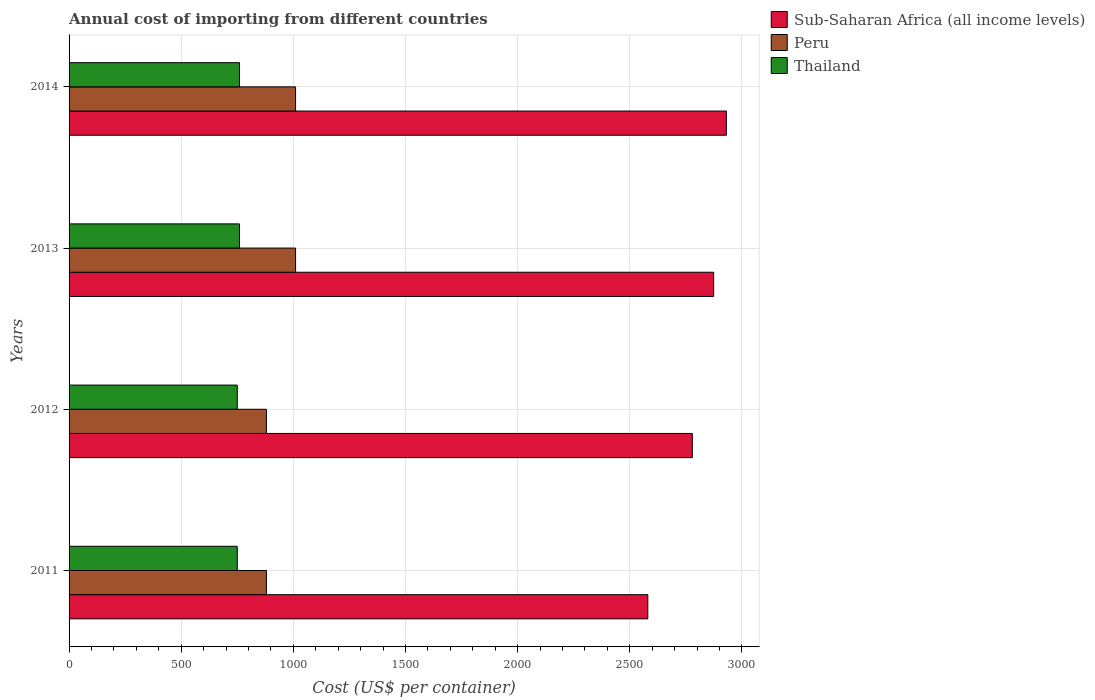How many different coloured bars are there?
Offer a very short reply. 3. How many groups of bars are there?
Your response must be concise. 4. Are the number of bars per tick equal to the number of legend labels?
Make the answer very short. Yes. How many bars are there on the 1st tick from the top?
Make the answer very short. 3. What is the label of the 3rd group of bars from the top?
Your answer should be compact. 2012. In how many cases, is the number of bars for a given year not equal to the number of legend labels?
Give a very brief answer. 0. What is the total annual cost of importing in Peru in 2014?
Your response must be concise. 1010. Across all years, what is the maximum total annual cost of importing in Peru?
Keep it short and to the point. 1010. Across all years, what is the minimum total annual cost of importing in Thailand?
Provide a short and direct response. 750. In which year was the total annual cost of importing in Peru maximum?
Keep it short and to the point. 2013. What is the total total annual cost of importing in Peru in the graph?
Your answer should be very brief. 3780. What is the difference between the total annual cost of importing in Thailand in 2012 and that in 2014?
Your answer should be compact. -10. What is the difference between the total annual cost of importing in Sub-Saharan Africa (all income levels) in 2011 and the total annual cost of importing in Thailand in 2012?
Provide a short and direct response. 1830.65. What is the average total annual cost of importing in Sub-Saharan Africa (all income levels) per year?
Keep it short and to the point. 2791.25. In the year 2012, what is the difference between the total annual cost of importing in Thailand and total annual cost of importing in Sub-Saharan Africa (all income levels)?
Your answer should be compact. -2029.19. In how many years, is the total annual cost of importing in Peru greater than 500 US$?
Offer a very short reply. 4. What is the ratio of the total annual cost of importing in Thailand in 2011 to that in 2014?
Your response must be concise. 0.99. Is the total annual cost of importing in Sub-Saharan Africa (all income levels) in 2011 less than that in 2013?
Ensure brevity in your answer.  Yes. Is the difference between the total annual cost of importing in Thailand in 2011 and 2012 greater than the difference between the total annual cost of importing in Sub-Saharan Africa (all income levels) in 2011 and 2012?
Your answer should be compact. Yes. What is the difference between the highest and the lowest total annual cost of importing in Thailand?
Your answer should be compact. 10. In how many years, is the total annual cost of importing in Thailand greater than the average total annual cost of importing in Thailand taken over all years?
Provide a short and direct response. 2. Is the sum of the total annual cost of importing in Thailand in 2012 and 2014 greater than the maximum total annual cost of importing in Peru across all years?
Make the answer very short. Yes. What does the 1st bar from the bottom in 2013 represents?
Give a very brief answer. Sub-Saharan Africa (all income levels). Is it the case that in every year, the sum of the total annual cost of importing in Peru and total annual cost of importing in Sub-Saharan Africa (all income levels) is greater than the total annual cost of importing in Thailand?
Your answer should be very brief. Yes. How many bars are there?
Your answer should be very brief. 12. Are all the bars in the graph horizontal?
Your answer should be compact. Yes. What is the difference between two consecutive major ticks on the X-axis?
Provide a succinct answer. 500. Are the values on the major ticks of X-axis written in scientific E-notation?
Ensure brevity in your answer.  No. Does the graph contain any zero values?
Keep it short and to the point. No. Where does the legend appear in the graph?
Your answer should be compact. Top right. What is the title of the graph?
Ensure brevity in your answer.  Annual cost of importing from different countries. What is the label or title of the X-axis?
Ensure brevity in your answer.  Cost (US$ per container). What is the Cost (US$ per container) in Sub-Saharan Africa (all income levels) in 2011?
Give a very brief answer. 2580.65. What is the Cost (US$ per container) of Peru in 2011?
Your response must be concise. 880. What is the Cost (US$ per container) in Thailand in 2011?
Provide a short and direct response. 750. What is the Cost (US$ per container) in Sub-Saharan Africa (all income levels) in 2012?
Your answer should be very brief. 2779.19. What is the Cost (US$ per container) in Peru in 2012?
Your response must be concise. 880. What is the Cost (US$ per container) of Thailand in 2012?
Provide a succinct answer. 750. What is the Cost (US$ per container) of Sub-Saharan Africa (all income levels) in 2013?
Your response must be concise. 2874.2. What is the Cost (US$ per container) of Peru in 2013?
Your response must be concise. 1010. What is the Cost (US$ per container) of Thailand in 2013?
Your response must be concise. 760. What is the Cost (US$ per container) of Sub-Saharan Africa (all income levels) in 2014?
Offer a very short reply. 2930.95. What is the Cost (US$ per container) of Peru in 2014?
Make the answer very short. 1010. What is the Cost (US$ per container) of Thailand in 2014?
Provide a short and direct response. 760. Across all years, what is the maximum Cost (US$ per container) in Sub-Saharan Africa (all income levels)?
Ensure brevity in your answer.  2930.95. Across all years, what is the maximum Cost (US$ per container) of Peru?
Your answer should be compact. 1010. Across all years, what is the maximum Cost (US$ per container) of Thailand?
Offer a terse response. 760. Across all years, what is the minimum Cost (US$ per container) of Sub-Saharan Africa (all income levels)?
Give a very brief answer. 2580.65. Across all years, what is the minimum Cost (US$ per container) in Peru?
Offer a terse response. 880. Across all years, what is the minimum Cost (US$ per container) in Thailand?
Offer a very short reply. 750. What is the total Cost (US$ per container) in Sub-Saharan Africa (all income levels) in the graph?
Give a very brief answer. 1.12e+04. What is the total Cost (US$ per container) of Peru in the graph?
Ensure brevity in your answer.  3780. What is the total Cost (US$ per container) in Thailand in the graph?
Your answer should be very brief. 3020. What is the difference between the Cost (US$ per container) in Sub-Saharan Africa (all income levels) in 2011 and that in 2012?
Give a very brief answer. -198.54. What is the difference between the Cost (US$ per container) of Thailand in 2011 and that in 2012?
Your answer should be compact. 0. What is the difference between the Cost (US$ per container) of Sub-Saharan Africa (all income levels) in 2011 and that in 2013?
Ensure brevity in your answer.  -293.55. What is the difference between the Cost (US$ per container) of Peru in 2011 and that in 2013?
Your response must be concise. -130. What is the difference between the Cost (US$ per container) in Sub-Saharan Africa (all income levels) in 2011 and that in 2014?
Your response must be concise. -350.29. What is the difference between the Cost (US$ per container) in Peru in 2011 and that in 2014?
Provide a short and direct response. -130. What is the difference between the Cost (US$ per container) in Thailand in 2011 and that in 2014?
Offer a terse response. -10. What is the difference between the Cost (US$ per container) of Sub-Saharan Africa (all income levels) in 2012 and that in 2013?
Provide a succinct answer. -95.01. What is the difference between the Cost (US$ per container) in Peru in 2012 and that in 2013?
Offer a very short reply. -130. What is the difference between the Cost (US$ per container) in Thailand in 2012 and that in 2013?
Your answer should be very brief. -10. What is the difference between the Cost (US$ per container) in Sub-Saharan Africa (all income levels) in 2012 and that in 2014?
Provide a short and direct response. -151.76. What is the difference between the Cost (US$ per container) in Peru in 2012 and that in 2014?
Make the answer very short. -130. What is the difference between the Cost (US$ per container) in Thailand in 2012 and that in 2014?
Keep it short and to the point. -10. What is the difference between the Cost (US$ per container) in Sub-Saharan Africa (all income levels) in 2013 and that in 2014?
Your response must be concise. -56.74. What is the difference between the Cost (US$ per container) of Sub-Saharan Africa (all income levels) in 2011 and the Cost (US$ per container) of Peru in 2012?
Offer a terse response. 1700.65. What is the difference between the Cost (US$ per container) of Sub-Saharan Africa (all income levels) in 2011 and the Cost (US$ per container) of Thailand in 2012?
Make the answer very short. 1830.65. What is the difference between the Cost (US$ per container) in Peru in 2011 and the Cost (US$ per container) in Thailand in 2012?
Your response must be concise. 130. What is the difference between the Cost (US$ per container) of Sub-Saharan Africa (all income levels) in 2011 and the Cost (US$ per container) of Peru in 2013?
Provide a succinct answer. 1570.65. What is the difference between the Cost (US$ per container) of Sub-Saharan Africa (all income levels) in 2011 and the Cost (US$ per container) of Thailand in 2013?
Provide a short and direct response. 1820.65. What is the difference between the Cost (US$ per container) in Peru in 2011 and the Cost (US$ per container) in Thailand in 2013?
Provide a short and direct response. 120. What is the difference between the Cost (US$ per container) of Sub-Saharan Africa (all income levels) in 2011 and the Cost (US$ per container) of Peru in 2014?
Offer a terse response. 1570.65. What is the difference between the Cost (US$ per container) of Sub-Saharan Africa (all income levels) in 2011 and the Cost (US$ per container) of Thailand in 2014?
Ensure brevity in your answer.  1820.65. What is the difference between the Cost (US$ per container) of Peru in 2011 and the Cost (US$ per container) of Thailand in 2014?
Your answer should be very brief. 120. What is the difference between the Cost (US$ per container) of Sub-Saharan Africa (all income levels) in 2012 and the Cost (US$ per container) of Peru in 2013?
Your answer should be compact. 1769.19. What is the difference between the Cost (US$ per container) in Sub-Saharan Africa (all income levels) in 2012 and the Cost (US$ per container) in Thailand in 2013?
Ensure brevity in your answer.  2019.19. What is the difference between the Cost (US$ per container) of Peru in 2012 and the Cost (US$ per container) of Thailand in 2013?
Give a very brief answer. 120. What is the difference between the Cost (US$ per container) of Sub-Saharan Africa (all income levels) in 2012 and the Cost (US$ per container) of Peru in 2014?
Your response must be concise. 1769.19. What is the difference between the Cost (US$ per container) of Sub-Saharan Africa (all income levels) in 2012 and the Cost (US$ per container) of Thailand in 2014?
Your response must be concise. 2019.19. What is the difference between the Cost (US$ per container) of Peru in 2012 and the Cost (US$ per container) of Thailand in 2014?
Your answer should be very brief. 120. What is the difference between the Cost (US$ per container) of Sub-Saharan Africa (all income levels) in 2013 and the Cost (US$ per container) of Peru in 2014?
Your response must be concise. 1864.2. What is the difference between the Cost (US$ per container) of Sub-Saharan Africa (all income levels) in 2013 and the Cost (US$ per container) of Thailand in 2014?
Provide a succinct answer. 2114.2. What is the difference between the Cost (US$ per container) in Peru in 2013 and the Cost (US$ per container) in Thailand in 2014?
Your answer should be compact. 250. What is the average Cost (US$ per container) in Sub-Saharan Africa (all income levels) per year?
Ensure brevity in your answer.  2791.25. What is the average Cost (US$ per container) of Peru per year?
Make the answer very short. 945. What is the average Cost (US$ per container) in Thailand per year?
Keep it short and to the point. 755. In the year 2011, what is the difference between the Cost (US$ per container) in Sub-Saharan Africa (all income levels) and Cost (US$ per container) in Peru?
Provide a short and direct response. 1700.65. In the year 2011, what is the difference between the Cost (US$ per container) in Sub-Saharan Africa (all income levels) and Cost (US$ per container) in Thailand?
Keep it short and to the point. 1830.65. In the year 2011, what is the difference between the Cost (US$ per container) in Peru and Cost (US$ per container) in Thailand?
Your answer should be compact. 130. In the year 2012, what is the difference between the Cost (US$ per container) in Sub-Saharan Africa (all income levels) and Cost (US$ per container) in Peru?
Your answer should be compact. 1899.19. In the year 2012, what is the difference between the Cost (US$ per container) in Sub-Saharan Africa (all income levels) and Cost (US$ per container) in Thailand?
Ensure brevity in your answer.  2029.19. In the year 2012, what is the difference between the Cost (US$ per container) in Peru and Cost (US$ per container) in Thailand?
Provide a short and direct response. 130. In the year 2013, what is the difference between the Cost (US$ per container) of Sub-Saharan Africa (all income levels) and Cost (US$ per container) of Peru?
Keep it short and to the point. 1864.2. In the year 2013, what is the difference between the Cost (US$ per container) in Sub-Saharan Africa (all income levels) and Cost (US$ per container) in Thailand?
Ensure brevity in your answer.  2114.2. In the year 2013, what is the difference between the Cost (US$ per container) of Peru and Cost (US$ per container) of Thailand?
Give a very brief answer. 250. In the year 2014, what is the difference between the Cost (US$ per container) of Sub-Saharan Africa (all income levels) and Cost (US$ per container) of Peru?
Make the answer very short. 1920.95. In the year 2014, what is the difference between the Cost (US$ per container) of Sub-Saharan Africa (all income levels) and Cost (US$ per container) of Thailand?
Your answer should be very brief. 2170.95. In the year 2014, what is the difference between the Cost (US$ per container) in Peru and Cost (US$ per container) in Thailand?
Provide a succinct answer. 250. What is the ratio of the Cost (US$ per container) in Thailand in 2011 to that in 2012?
Offer a terse response. 1. What is the ratio of the Cost (US$ per container) of Sub-Saharan Africa (all income levels) in 2011 to that in 2013?
Your response must be concise. 0.9. What is the ratio of the Cost (US$ per container) in Peru in 2011 to that in 2013?
Provide a succinct answer. 0.87. What is the ratio of the Cost (US$ per container) of Thailand in 2011 to that in 2013?
Your answer should be very brief. 0.99. What is the ratio of the Cost (US$ per container) of Sub-Saharan Africa (all income levels) in 2011 to that in 2014?
Offer a very short reply. 0.88. What is the ratio of the Cost (US$ per container) of Peru in 2011 to that in 2014?
Provide a succinct answer. 0.87. What is the ratio of the Cost (US$ per container) in Sub-Saharan Africa (all income levels) in 2012 to that in 2013?
Your answer should be compact. 0.97. What is the ratio of the Cost (US$ per container) in Peru in 2012 to that in 2013?
Make the answer very short. 0.87. What is the ratio of the Cost (US$ per container) in Sub-Saharan Africa (all income levels) in 2012 to that in 2014?
Offer a very short reply. 0.95. What is the ratio of the Cost (US$ per container) in Peru in 2012 to that in 2014?
Provide a succinct answer. 0.87. What is the ratio of the Cost (US$ per container) in Thailand in 2012 to that in 2014?
Offer a very short reply. 0.99. What is the ratio of the Cost (US$ per container) of Sub-Saharan Africa (all income levels) in 2013 to that in 2014?
Offer a terse response. 0.98. What is the ratio of the Cost (US$ per container) in Peru in 2013 to that in 2014?
Offer a very short reply. 1. What is the difference between the highest and the second highest Cost (US$ per container) of Sub-Saharan Africa (all income levels)?
Offer a terse response. 56.74. What is the difference between the highest and the second highest Cost (US$ per container) of Thailand?
Provide a succinct answer. 0. What is the difference between the highest and the lowest Cost (US$ per container) in Sub-Saharan Africa (all income levels)?
Give a very brief answer. 350.29. What is the difference between the highest and the lowest Cost (US$ per container) in Peru?
Ensure brevity in your answer.  130. What is the difference between the highest and the lowest Cost (US$ per container) in Thailand?
Keep it short and to the point. 10. 